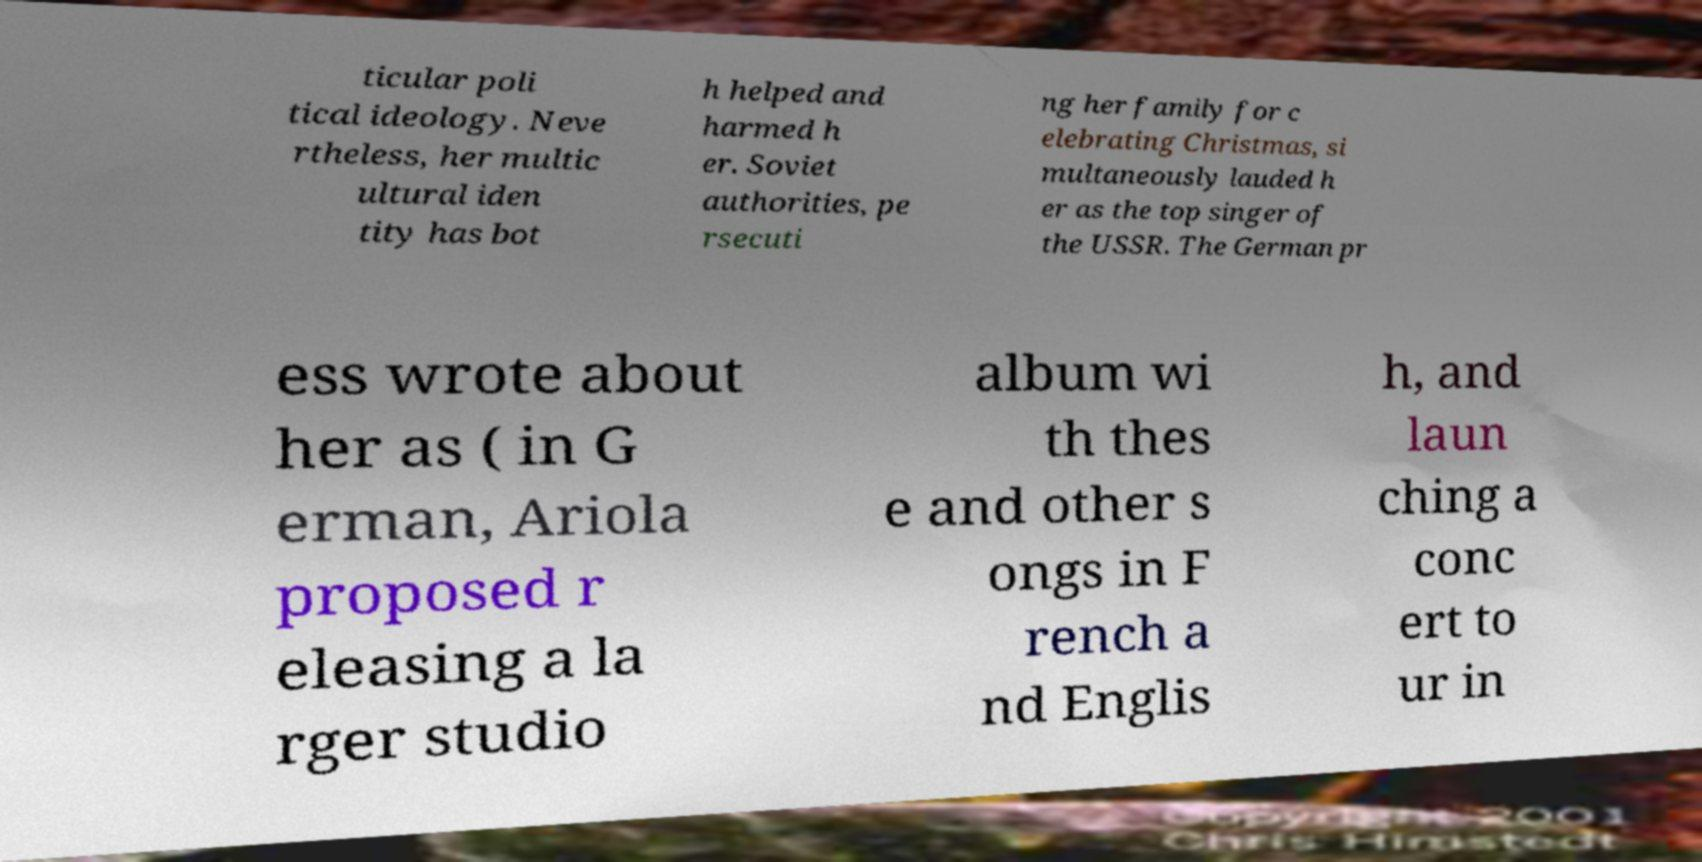Could you assist in decoding the text presented in this image and type it out clearly? ticular poli tical ideology. Neve rtheless, her multic ultural iden tity has bot h helped and harmed h er. Soviet authorities, pe rsecuti ng her family for c elebrating Christmas, si multaneously lauded h er as the top singer of the USSR. The German pr ess wrote about her as ( in G erman, Ariola proposed r eleasing a la rger studio album wi th thes e and other s ongs in F rench a nd Englis h, and laun ching a conc ert to ur in 